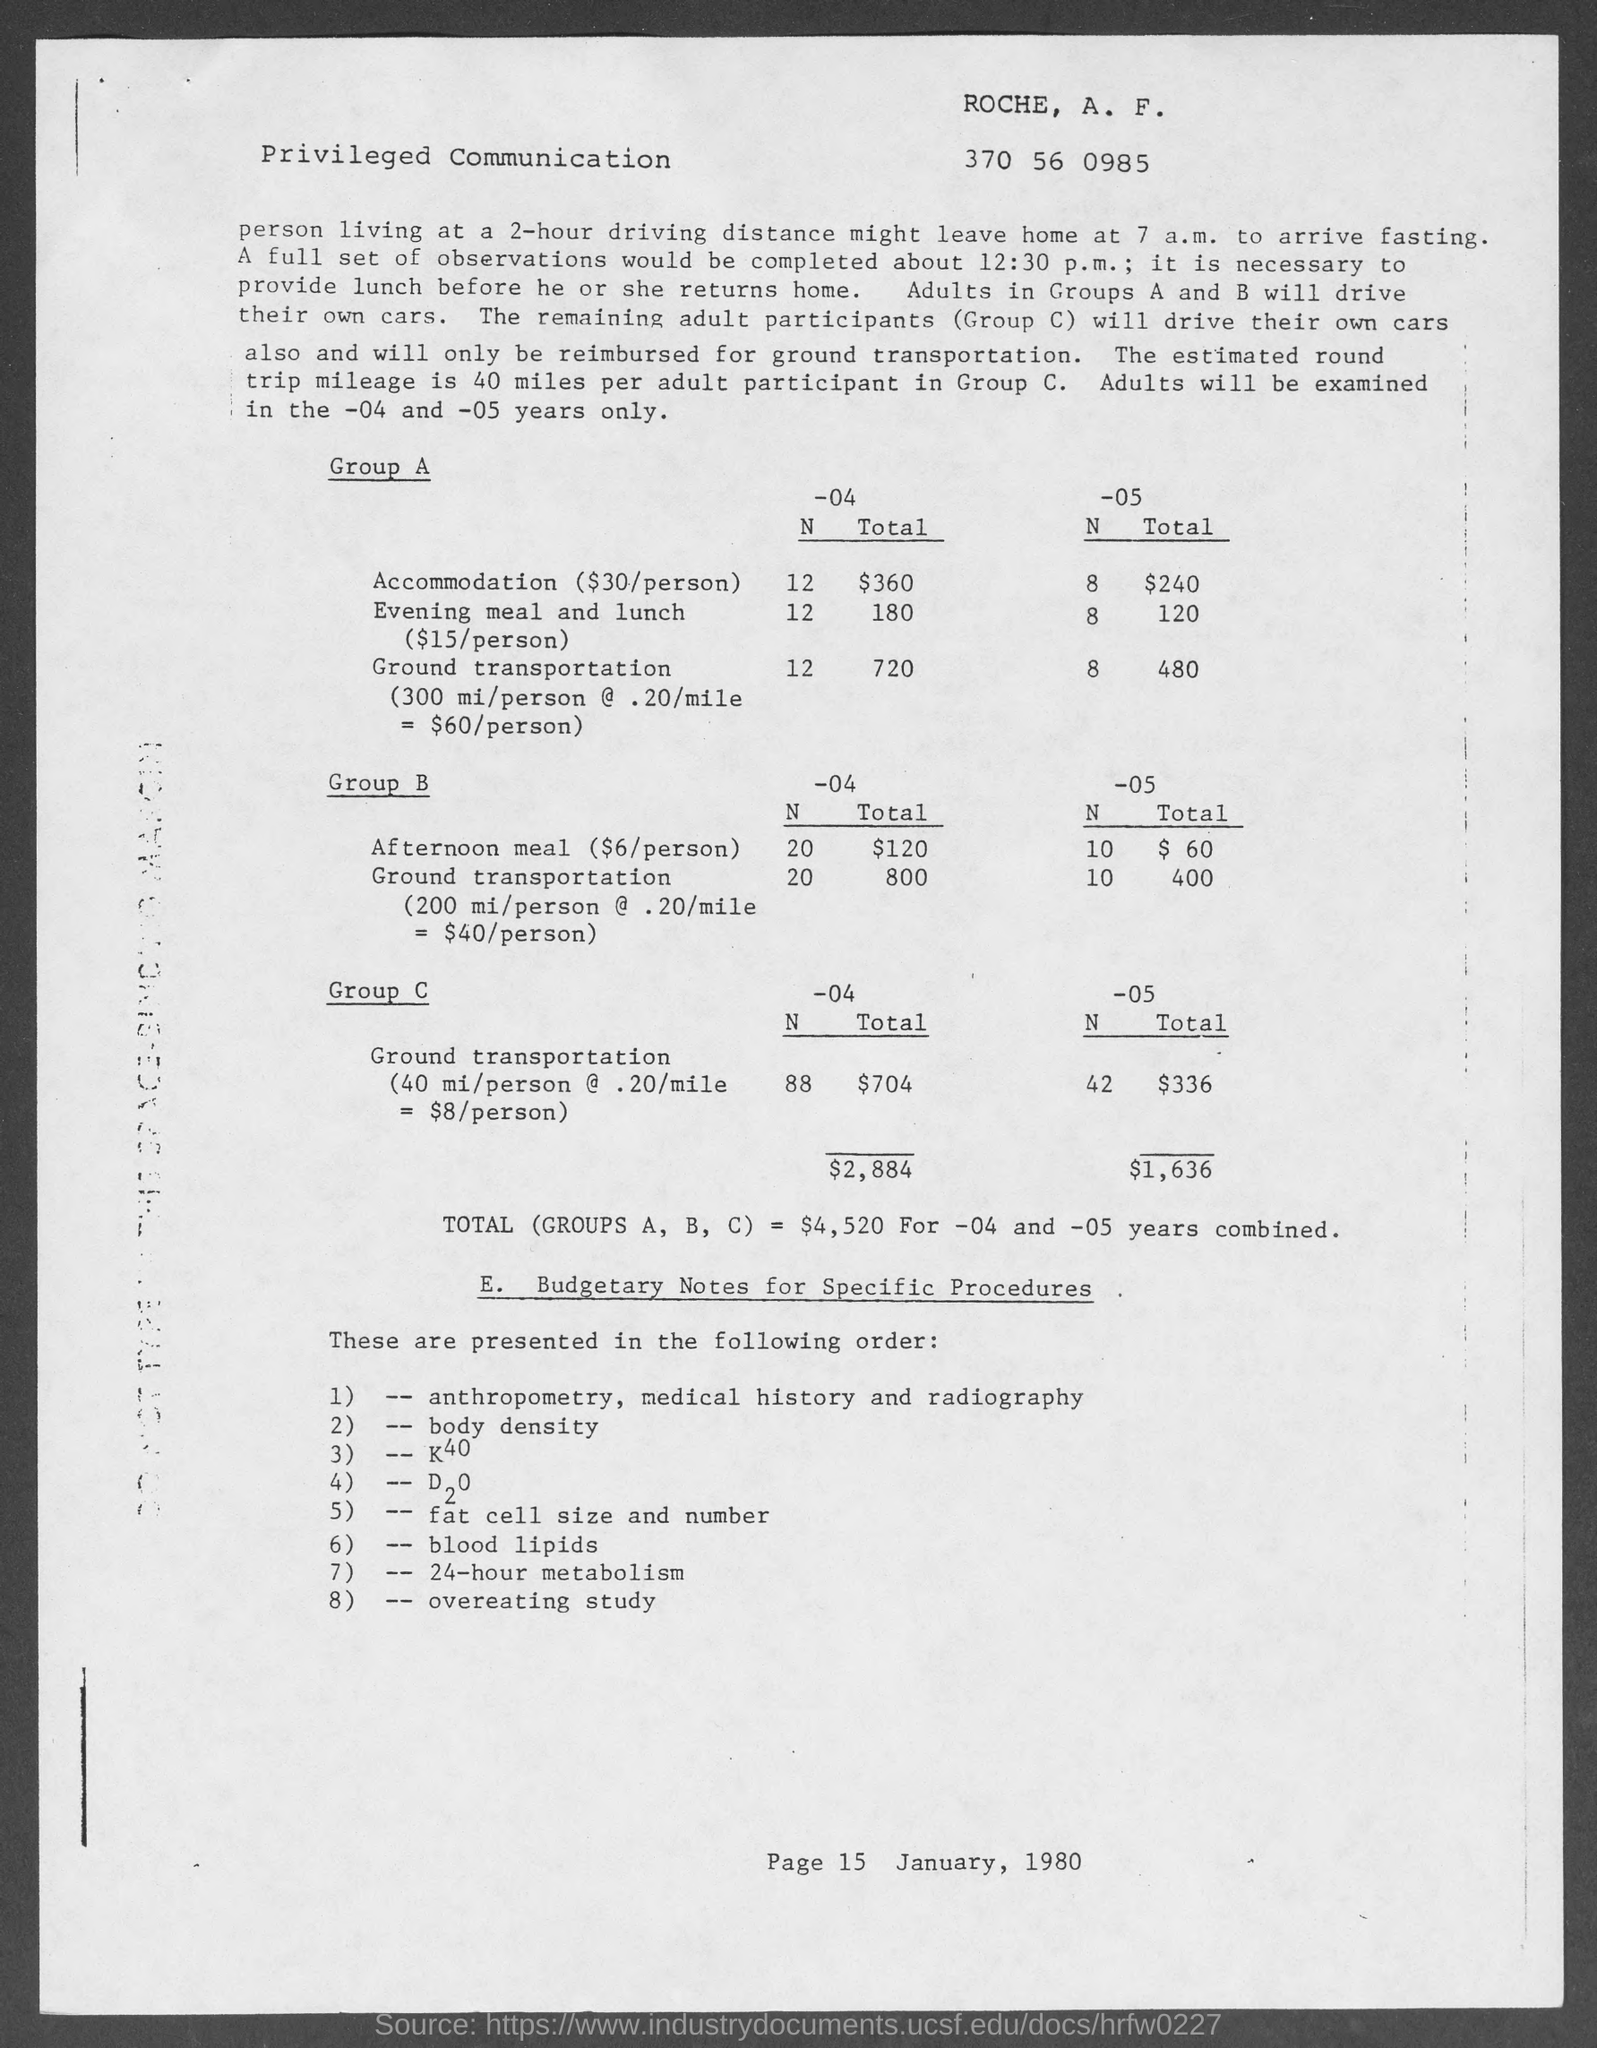Outline some significant characteristics in this image. The page number is 15. The document provides information regarding a date, specifically January 1980. 